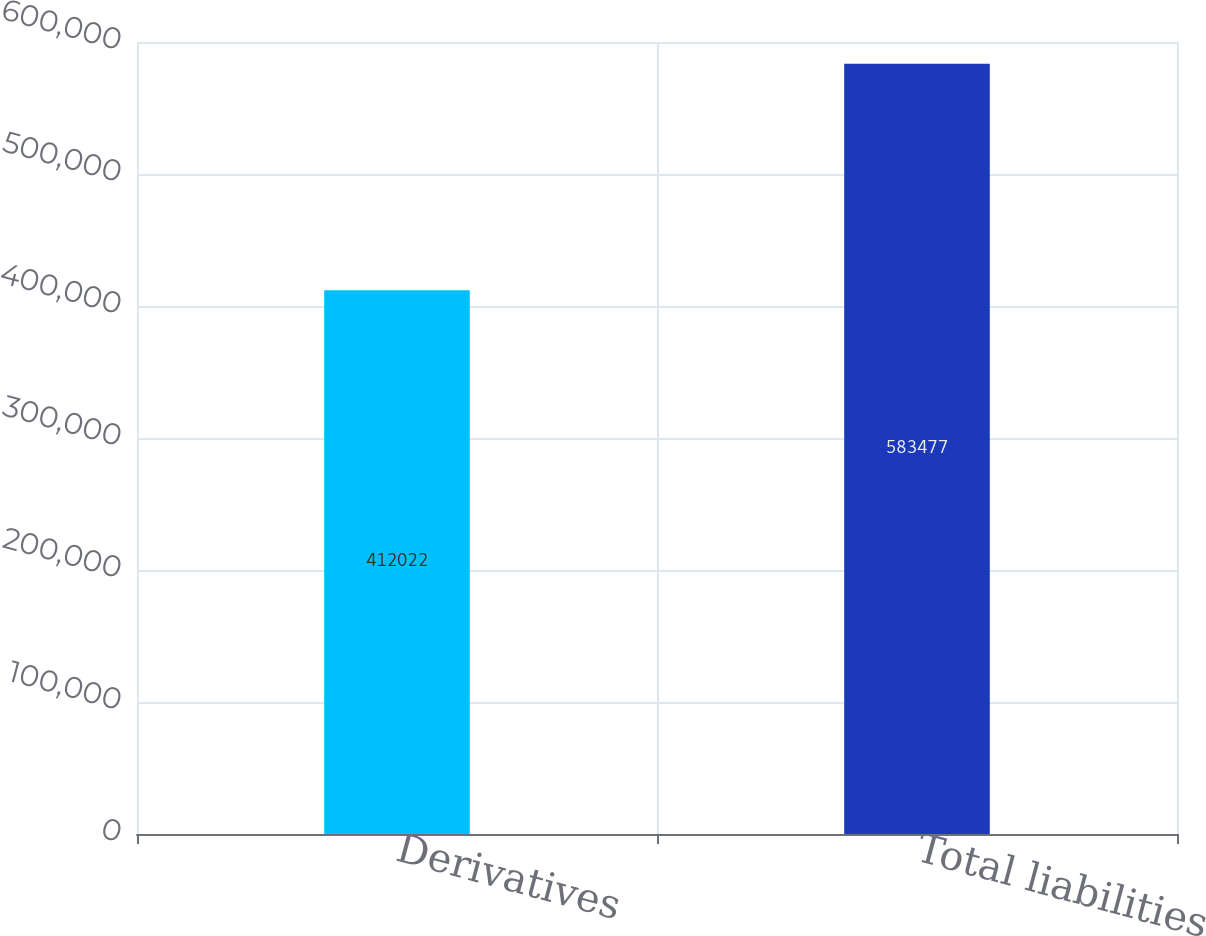Convert chart to OTSL. <chart><loc_0><loc_0><loc_500><loc_500><bar_chart><fcel>Derivatives<fcel>Total liabilities<nl><fcel>412022<fcel>583477<nl></chart> 